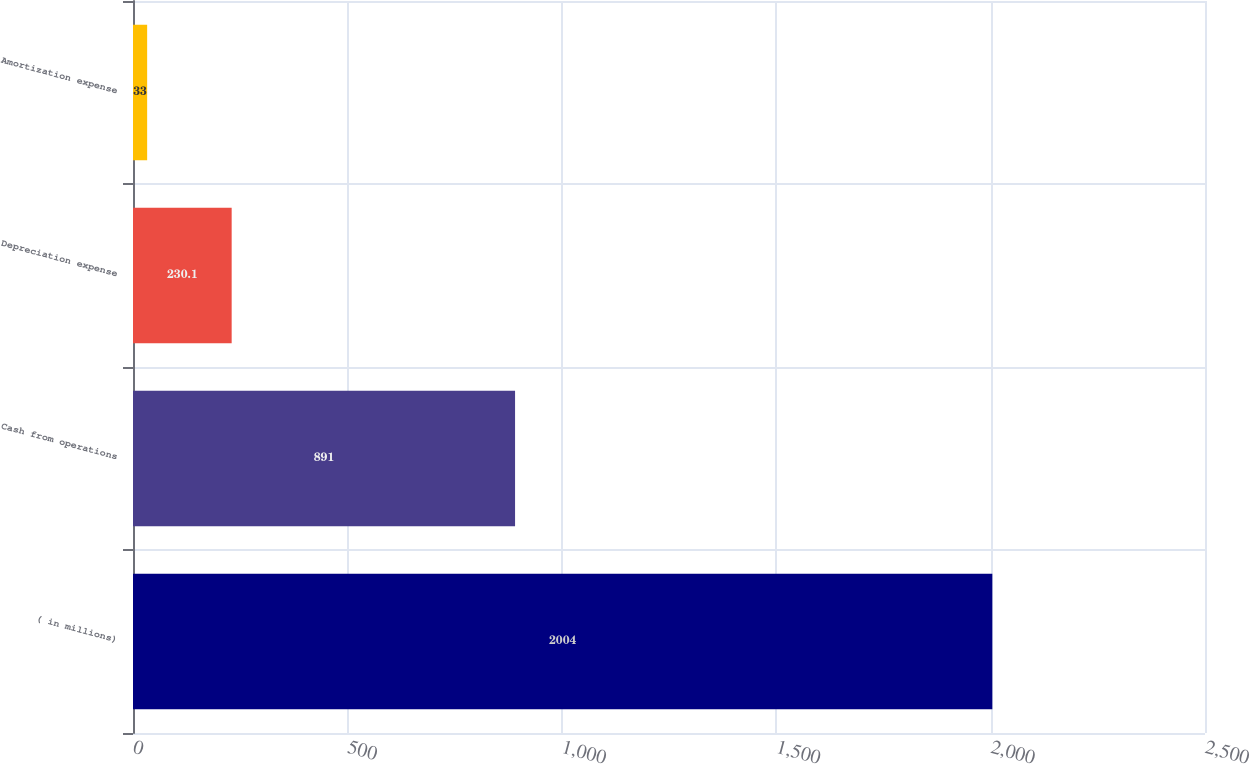Convert chart. <chart><loc_0><loc_0><loc_500><loc_500><bar_chart><fcel>( in millions)<fcel>Cash from operations<fcel>Depreciation expense<fcel>Amortization expense<nl><fcel>2004<fcel>891<fcel>230.1<fcel>33<nl></chart> 